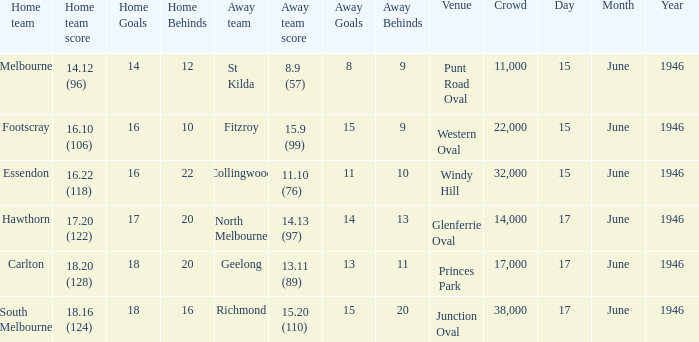Help me parse the entirety of this table. {'header': ['Home team', 'Home team score', 'Home Goals', 'Home Behinds', 'Away team', 'Away team score', 'Away Goals', 'Away Behinds', 'Venue', 'Crowd', 'Day', 'Month', 'Year'], 'rows': [['Melbourne', '14.12 (96)', '14', '12', 'St Kilda', '8.9 (57)', '8', '9', 'Punt Road Oval', '11,000', '15', 'June', '1946'], ['Footscray', '16.10 (106)', '16', '10', 'Fitzroy', '15.9 (99)', '15', '9', 'Western Oval', '22,000', '15', 'June', '1946'], ['Essendon', '16.22 (118)', '16', '22', 'Collingwood', '11.10 (76)', '11', '10', 'Windy Hill', '32,000', '15', 'June', '1946'], ['Hawthorn', '17.20 (122)', '17', '20', 'North Melbourne', '14.13 (97)', '14', '13', 'Glenferrie Oval', '14,000', '17', 'June', '1946'], ['Carlton', '18.20 (128)', '18', '20', 'Geelong', '13.11 (89)', '13', '11', 'Princes Park', '17,000', '17', 'June', '1946'], ['South Melbourne', '18.16 (124)', '18', '16', 'Richmond', '15.20 (110)', '15', '20', 'Junction Oval', '38,000', '17', 'June', '1946']]} On what date did a home team score 16.10 (106)? 15 June 1946. 